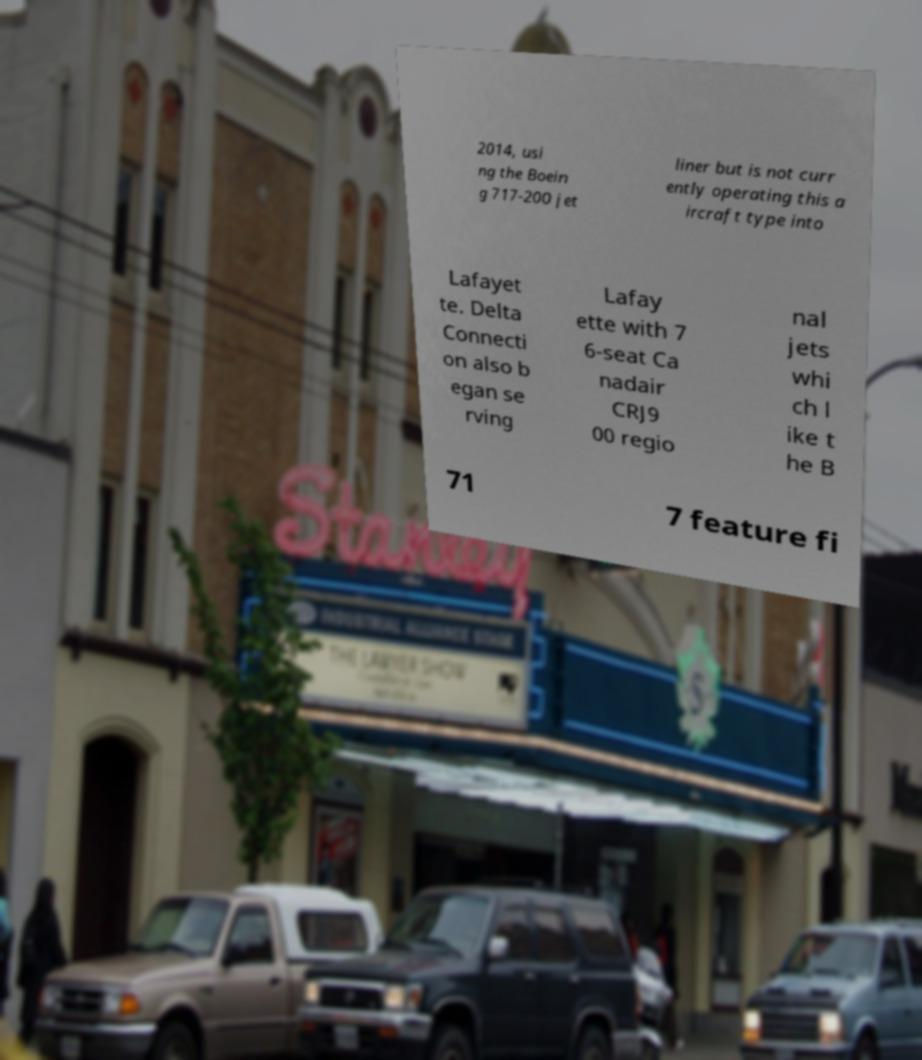Can you accurately transcribe the text from the provided image for me? 2014, usi ng the Boein g 717-200 jet liner but is not curr ently operating this a ircraft type into Lafayet te. Delta Connecti on also b egan se rving Lafay ette with 7 6-seat Ca nadair CRJ9 00 regio nal jets whi ch l ike t he B 71 7 feature fi 